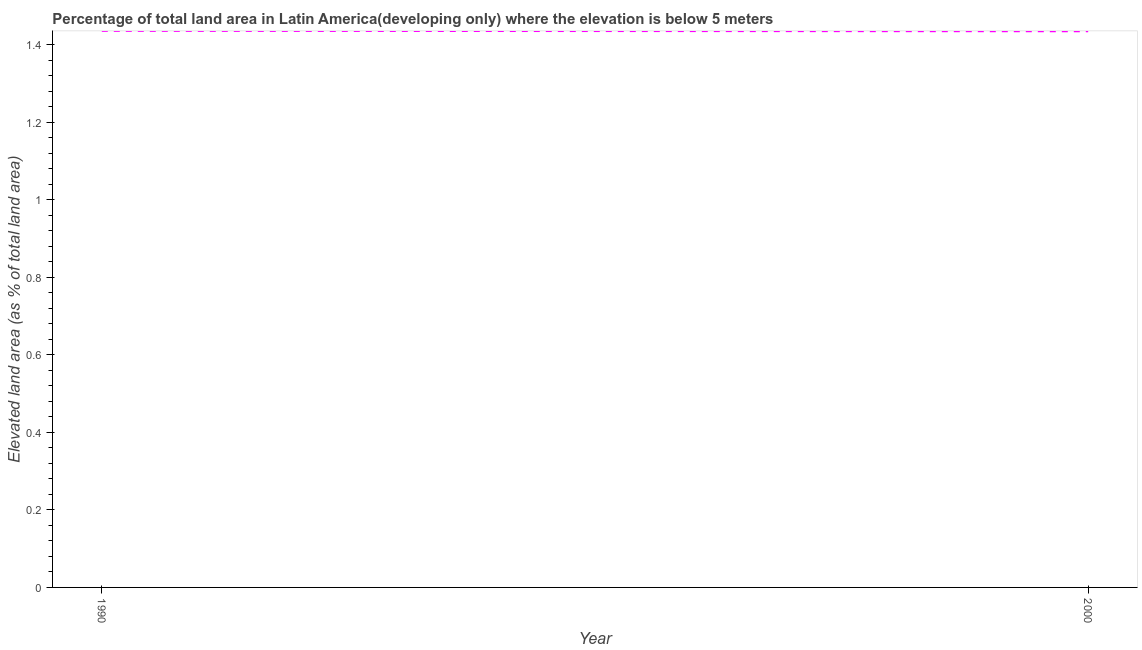What is the total elevated land area in 1990?
Offer a very short reply. 1.44. Across all years, what is the maximum total elevated land area?
Provide a succinct answer. 1.44. Across all years, what is the minimum total elevated land area?
Your response must be concise. 1.44. In which year was the total elevated land area minimum?
Offer a very short reply. 2000. What is the sum of the total elevated land area?
Offer a very short reply. 2.87. What is the difference between the total elevated land area in 1990 and 2000?
Offer a very short reply. 0. What is the average total elevated land area per year?
Keep it short and to the point. 1.44. What is the median total elevated land area?
Your answer should be compact. 1.44. In how many years, is the total elevated land area greater than 1.36 %?
Keep it short and to the point. 2. Do a majority of the years between 1990 and 2000 (inclusive) have total elevated land area greater than 0.68 %?
Your response must be concise. Yes. What is the ratio of the total elevated land area in 1990 to that in 2000?
Keep it short and to the point. 1. Is the total elevated land area in 1990 less than that in 2000?
Your answer should be very brief. No. Does the total elevated land area monotonically increase over the years?
Offer a very short reply. No. How many years are there in the graph?
Make the answer very short. 2. What is the difference between two consecutive major ticks on the Y-axis?
Keep it short and to the point. 0.2. Does the graph contain any zero values?
Your answer should be very brief. No. What is the title of the graph?
Your response must be concise. Percentage of total land area in Latin America(developing only) where the elevation is below 5 meters. What is the label or title of the X-axis?
Keep it short and to the point. Year. What is the label or title of the Y-axis?
Your answer should be very brief. Elevated land area (as % of total land area). What is the Elevated land area (as % of total land area) in 1990?
Offer a terse response. 1.44. What is the Elevated land area (as % of total land area) in 2000?
Offer a terse response. 1.44. What is the difference between the Elevated land area (as % of total land area) in 1990 and 2000?
Your answer should be compact. 0. 